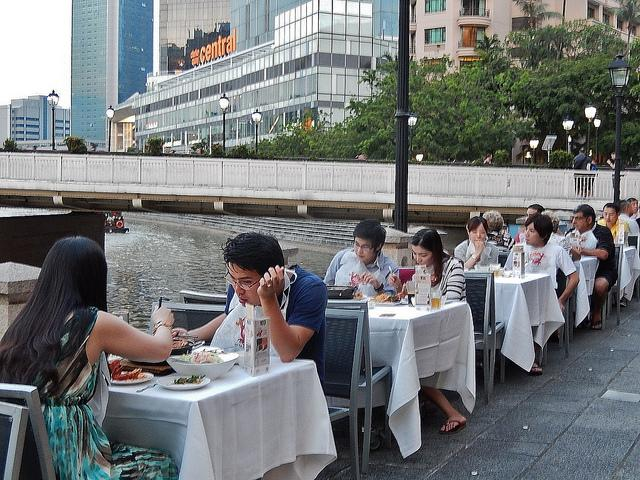What kind of meal are they having?

Choices:
A) steak
B) chicken
C) lobster
D) vegetarian lobster 